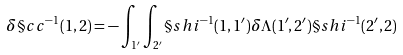<formula> <loc_0><loc_0><loc_500><loc_500>\delta \S c c ^ { - 1 } ( 1 , 2 ) = - \int _ { 1 ^ { \prime } } \int _ { 2 ^ { \prime } } \S s h i ^ { - 1 } ( 1 , 1 ^ { \prime } ) \delta \Lambda ( 1 ^ { \prime } , 2 ^ { \prime } ) \S s h i ^ { - 1 } ( 2 ^ { \prime } , 2 )</formula> 